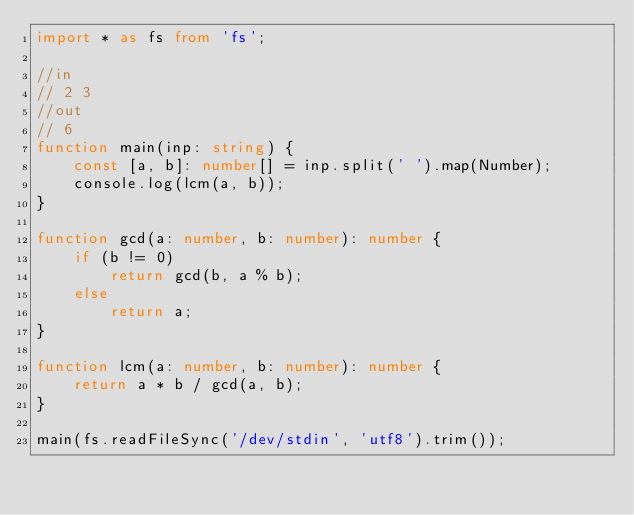Convert code to text. <code><loc_0><loc_0><loc_500><loc_500><_TypeScript_>import * as fs from 'fs';

//in
// 2 3
//out
// 6
function main(inp: string) {
    const [a, b]: number[] = inp.split(' ').map(Number);
    console.log(lcm(a, b));
}

function gcd(a: number, b: number): number {
    if (b != 0)
        return gcd(b, a % b);
    else
        return a;
}

function lcm(a: number, b: number): number {
    return a * b / gcd(a, b);
}

main(fs.readFileSync('/dev/stdin', 'utf8').trim());</code> 